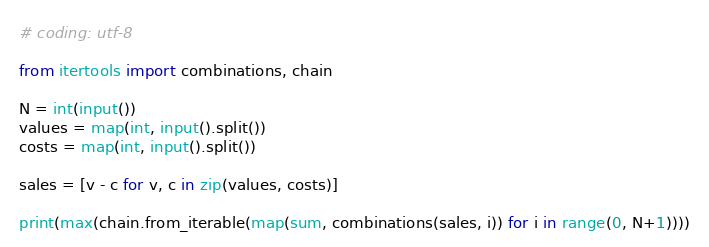<code> <loc_0><loc_0><loc_500><loc_500><_Python_># coding: utf-8

from itertools import combinations, chain

N = int(input())
values = map(int, input().split())
costs = map(int, input().split())

sales = [v - c for v, c in zip(values, costs)]

print(max(chain.from_iterable(map(sum, combinations(sales, i)) for i in range(0, N+1))))
</code> 